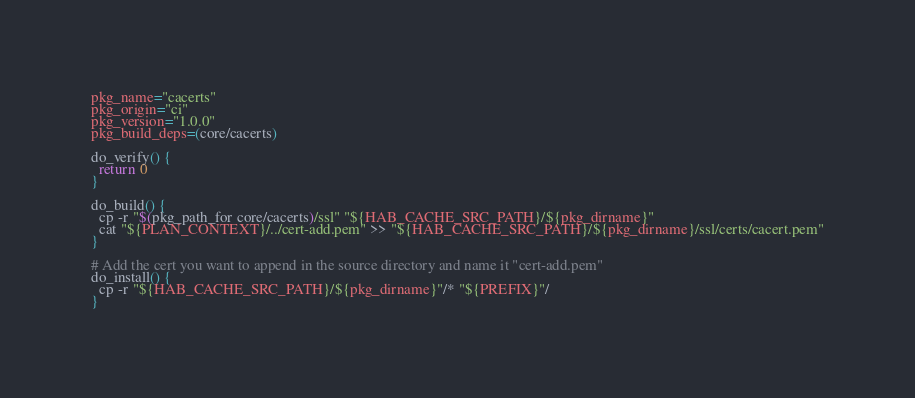Convert code to text. <code><loc_0><loc_0><loc_500><loc_500><_Bash_>pkg_name="cacerts"
pkg_origin="ci"
pkg_version="1.0.0"
pkg_build_deps=(core/cacerts)

do_verify() {
  return 0
}

do_build() {
  cp -r "$(pkg_path_for core/cacerts)/ssl" "${HAB_CACHE_SRC_PATH}/${pkg_dirname}"
  cat "${PLAN_CONTEXT}/../cert-add.pem" >> "${HAB_CACHE_SRC_PATH}/${pkg_dirname}/ssl/certs/cacert.pem"
}

# Add the cert you want to append in the source directory and name it "cert-add.pem"
do_install() {
  cp -r "${HAB_CACHE_SRC_PATH}/${pkg_dirname}"/* "${PREFIX}"/
}
</code> 